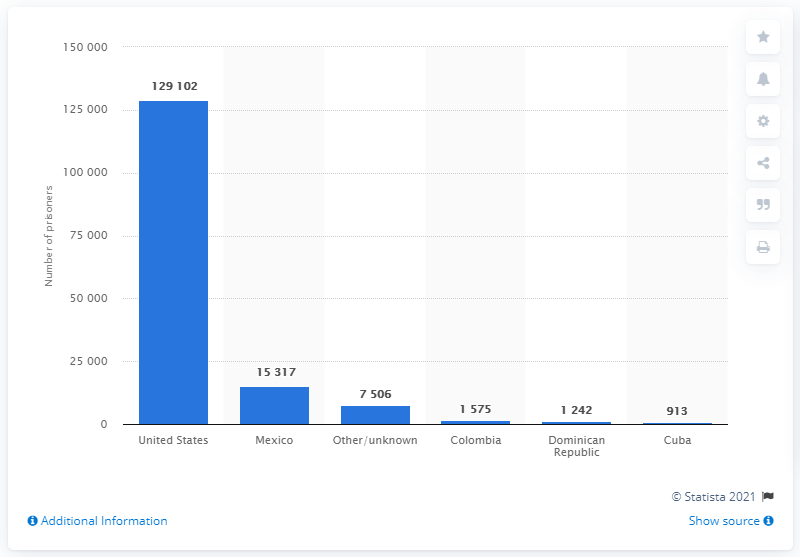Give some essential details in this illustration. As of August 29, 2020, it is known that 1,575 prisoners in the United States were from Colombia. 